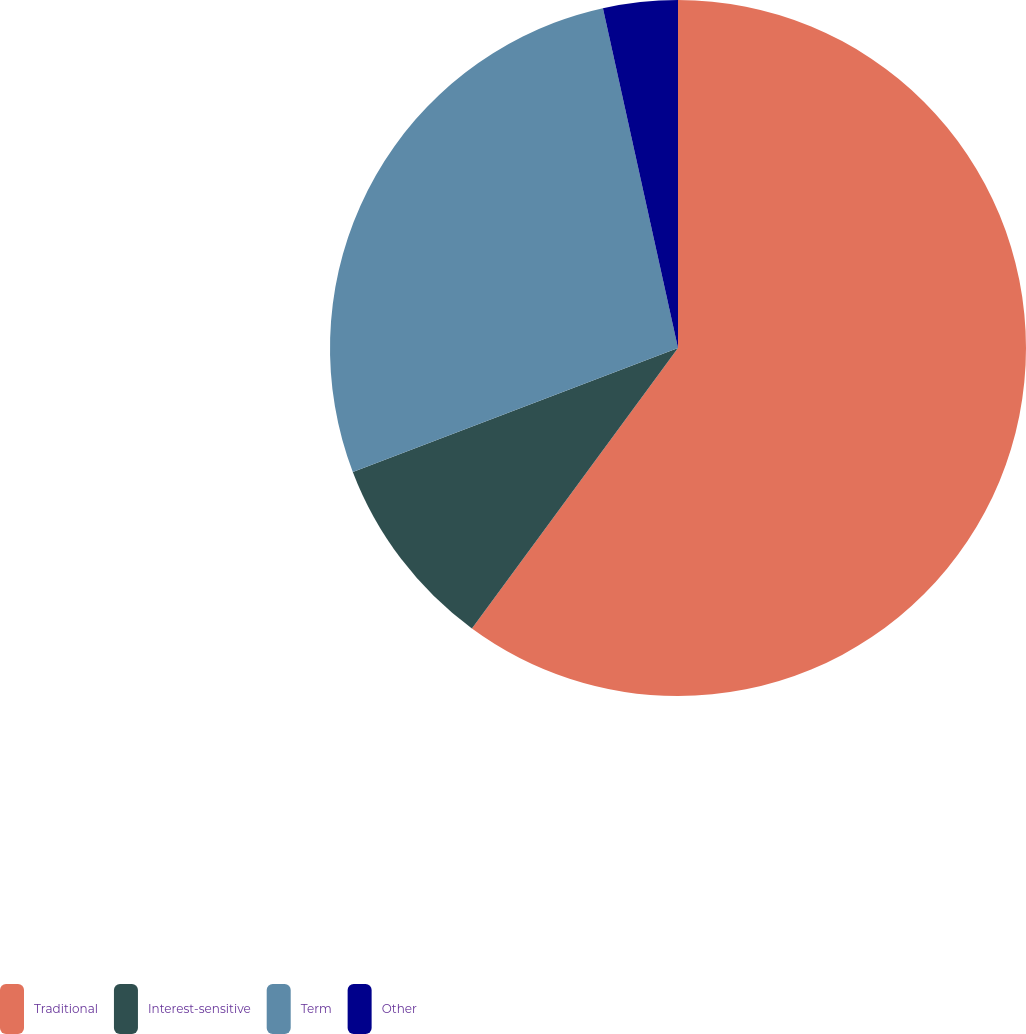Convert chart. <chart><loc_0><loc_0><loc_500><loc_500><pie_chart><fcel>Traditional<fcel>Interest-sensitive<fcel>Term<fcel>Other<nl><fcel>60.08%<fcel>9.12%<fcel>27.33%<fcel>3.46%<nl></chart> 